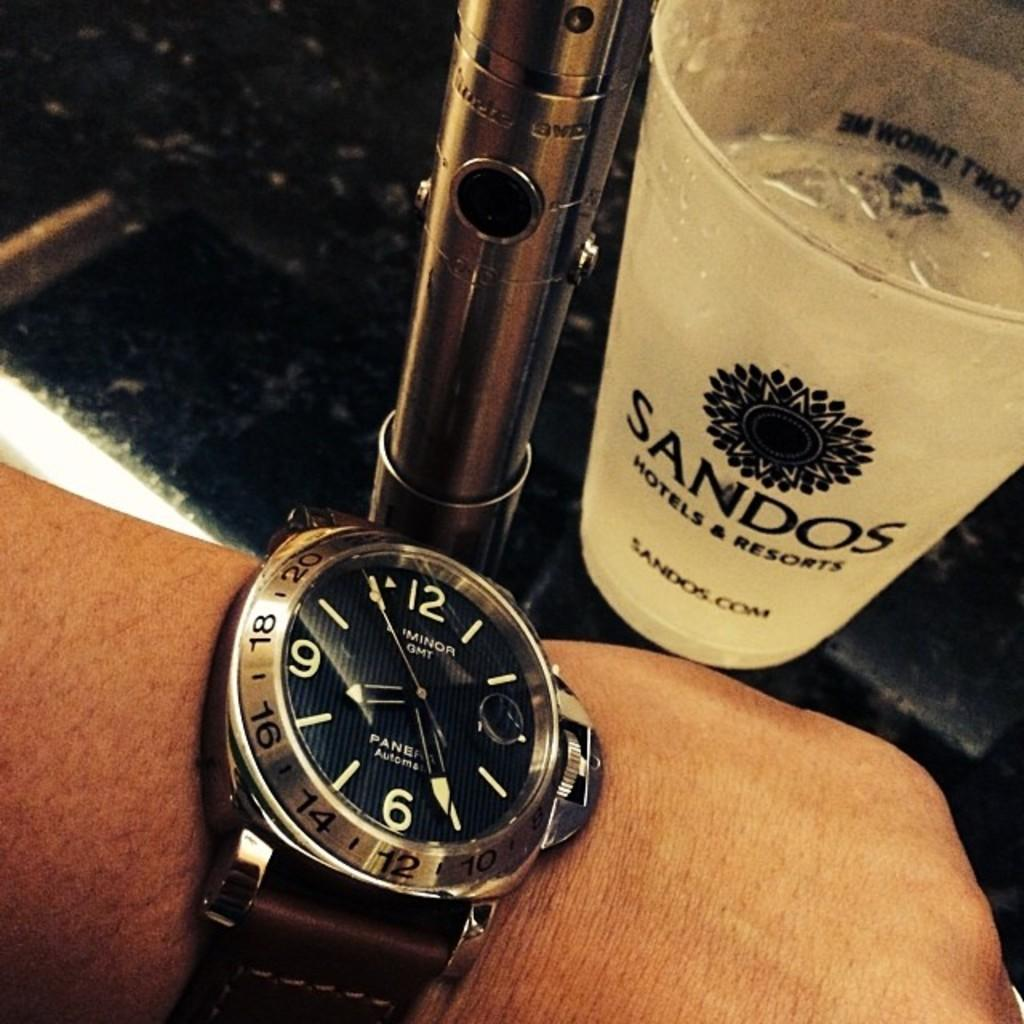<image>
Provide a brief description of the given image. A cup has a Sandos logo on the front of it. 